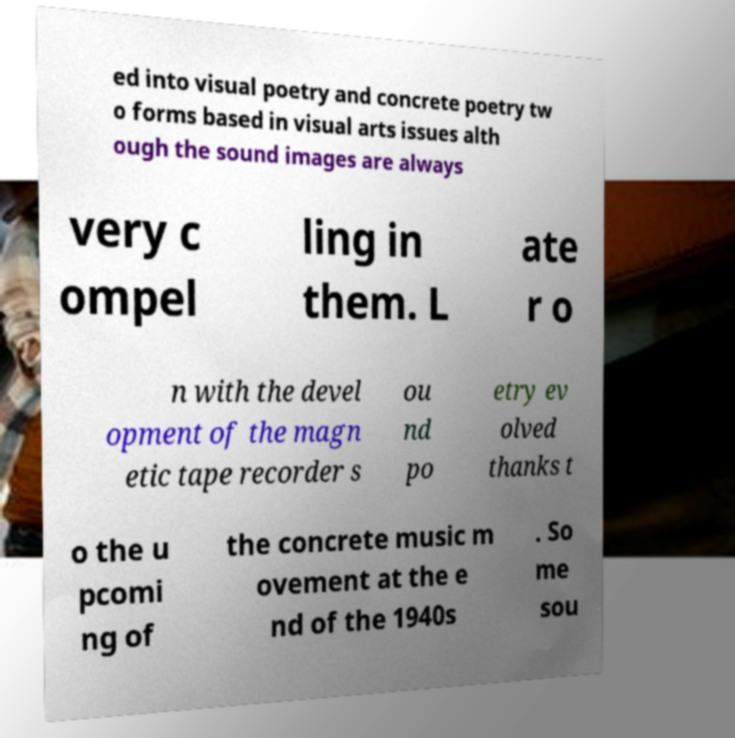Can you accurately transcribe the text from the provided image for me? ed into visual poetry and concrete poetry tw o forms based in visual arts issues alth ough the sound images are always very c ompel ling in them. L ate r o n with the devel opment of the magn etic tape recorder s ou nd po etry ev olved thanks t o the u pcomi ng of the concrete music m ovement at the e nd of the 1940s . So me sou 